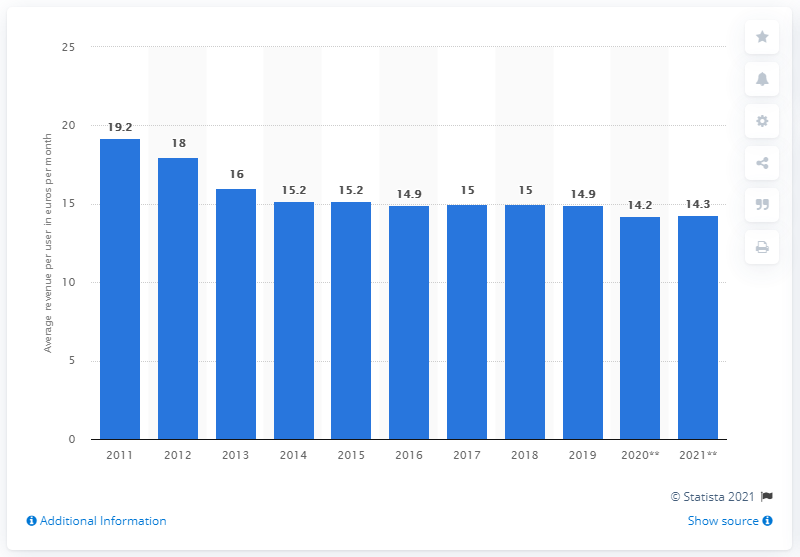How would this information be valuable for mobile broadband providers or investors? This data is crucial for providers and investors as it can help in assessing the health and profitability of the mobile broadband market in Europe. Understanding the trend in ARPU allows them to make informed decisions about strategic pricing, investment in infrastructure, and development of new services to either counteract the decline or leverage potential new revenue streams. For investors, it can indicate the market's potential return on investment and help in evaluating whether they should increase or decrease their stakes. 